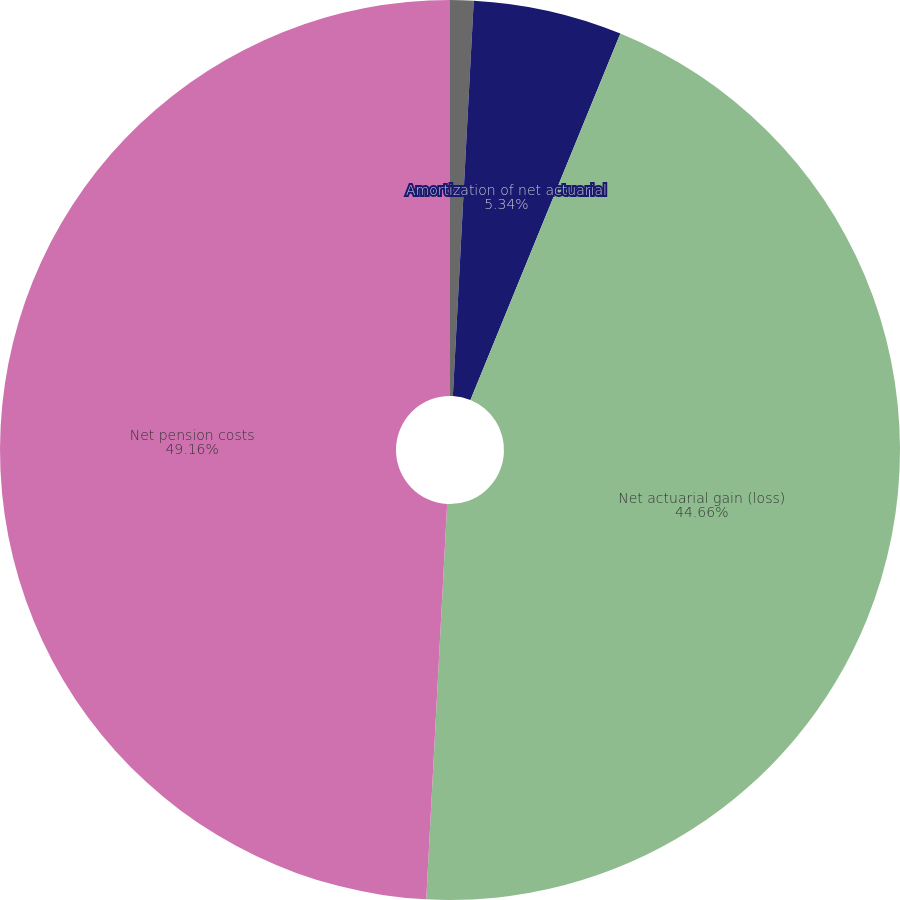<chart> <loc_0><loc_0><loc_500><loc_500><pie_chart><fcel>Amortization of prior service<fcel>Amortization of net actuarial<fcel>Net actuarial gain (loss)<fcel>Net pension costs<nl><fcel>0.84%<fcel>5.34%<fcel>44.66%<fcel>49.16%<nl></chart> 